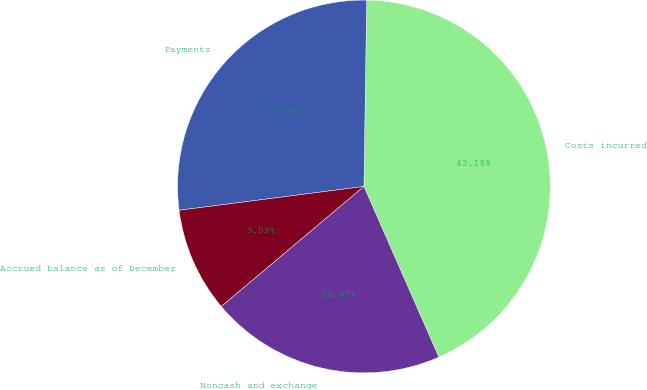Convert chart to OTSL. <chart><loc_0><loc_0><loc_500><loc_500><pie_chart><fcel>Costs incurred<fcel>Payments<fcel>Accrued balance as of December<fcel>Noncash and exchange<nl><fcel>43.18%<fcel>27.27%<fcel>9.09%<fcel>20.45%<nl></chart> 